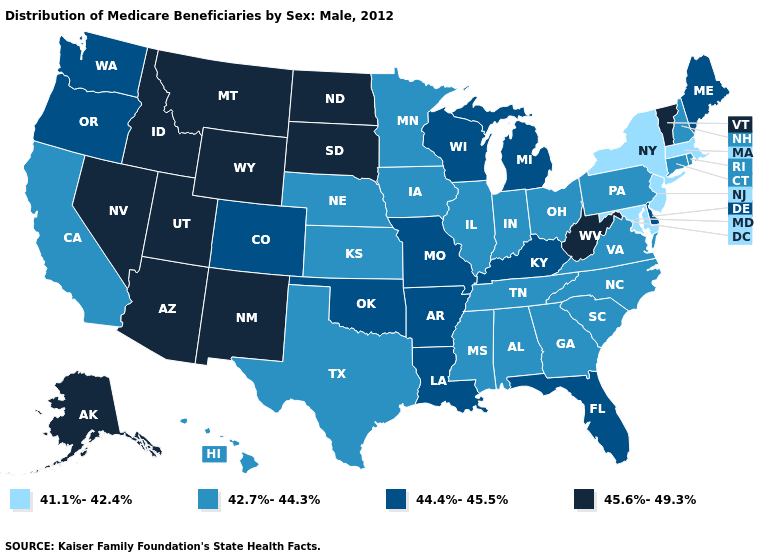Does Oregon have a higher value than Florida?
Give a very brief answer. No. What is the highest value in states that border Idaho?
Write a very short answer. 45.6%-49.3%. What is the value of Massachusetts?
Concise answer only. 41.1%-42.4%. Among the states that border Ohio , which have the highest value?
Write a very short answer. West Virginia. Does Idaho have a lower value than Arkansas?
Be succinct. No. Which states hav the highest value in the West?
Keep it brief. Alaska, Arizona, Idaho, Montana, Nevada, New Mexico, Utah, Wyoming. What is the value of Arizona?
Answer briefly. 45.6%-49.3%. Name the states that have a value in the range 41.1%-42.4%?
Be succinct. Maryland, Massachusetts, New Jersey, New York. Name the states that have a value in the range 42.7%-44.3%?
Be succinct. Alabama, California, Connecticut, Georgia, Hawaii, Illinois, Indiana, Iowa, Kansas, Minnesota, Mississippi, Nebraska, New Hampshire, North Carolina, Ohio, Pennsylvania, Rhode Island, South Carolina, Tennessee, Texas, Virginia. What is the value of Missouri?
Short answer required. 44.4%-45.5%. Which states have the lowest value in the West?
Quick response, please. California, Hawaii. What is the lowest value in the USA?
Quick response, please. 41.1%-42.4%. Name the states that have a value in the range 41.1%-42.4%?
Concise answer only. Maryland, Massachusetts, New Jersey, New York. Does California have the lowest value in the USA?
Keep it brief. No. Name the states that have a value in the range 41.1%-42.4%?
Be succinct. Maryland, Massachusetts, New Jersey, New York. 